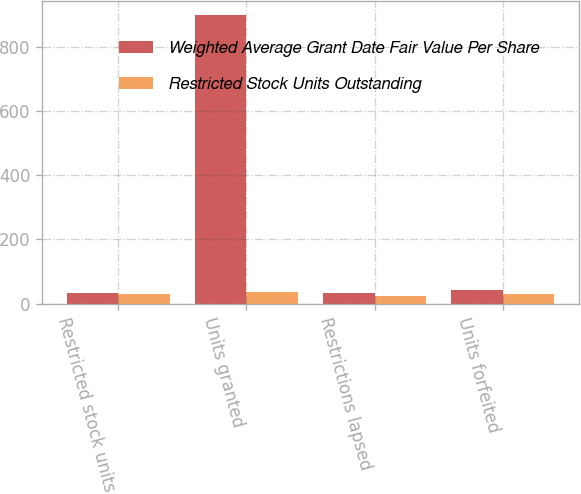<chart> <loc_0><loc_0><loc_500><loc_500><stacked_bar_chart><ecel><fcel>Restricted stock units<fcel>Units granted<fcel>Restrictions lapsed<fcel>Units forfeited<nl><fcel>Weighted Average Grant Date Fair Value Per Share<fcel>33<fcel>898<fcel>33<fcel>42<nl><fcel>Restricted Stock Units Outstanding<fcel>31.1<fcel>34.93<fcel>24.28<fcel>31.39<nl></chart> 